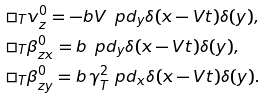Convert formula to latex. <formula><loc_0><loc_0><loc_500><loc_500>& \square _ { T } v _ { z } ^ { 0 } = - b V \, \ p d _ { y } \delta ( x - V t ) \delta ( y ) , \\ & \square _ { T } \beta _ { z x } ^ { 0 } = b \, \ p d _ { y } \delta ( x - V t ) \delta ( y ) , \\ & \square _ { T } \beta _ { z y } ^ { 0 } = b \, \gamma ^ { 2 } _ { T } \ p d _ { x } \delta ( x - V t ) \delta ( y ) .</formula> 